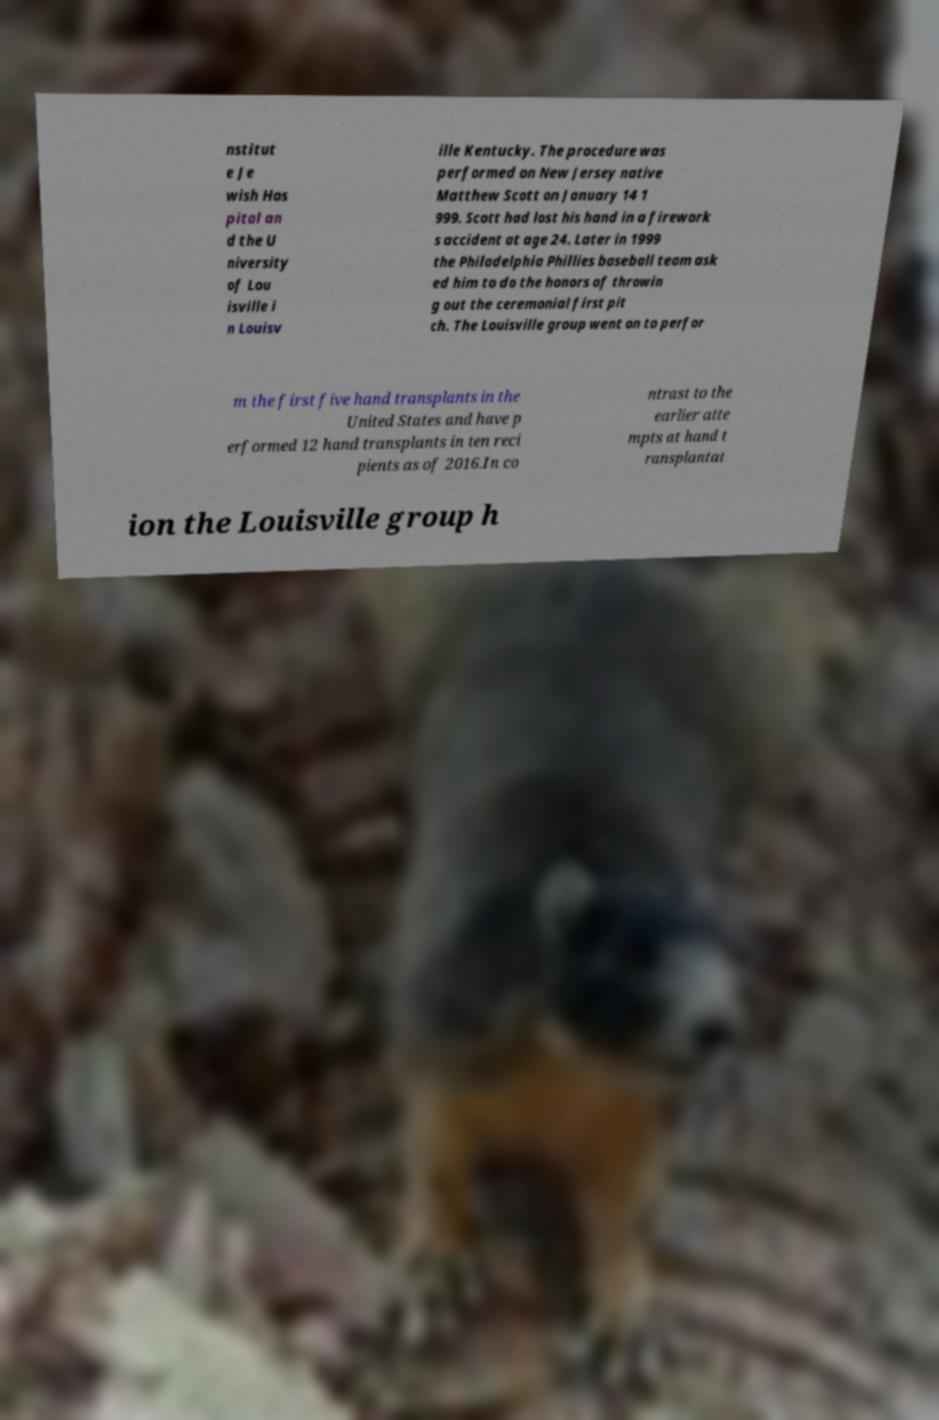For documentation purposes, I need the text within this image transcribed. Could you provide that? nstitut e Je wish Hos pital an d the U niversity of Lou isville i n Louisv ille Kentucky. The procedure was performed on New Jersey native Matthew Scott on January 14 1 999. Scott had lost his hand in a firework s accident at age 24. Later in 1999 the Philadelphia Phillies baseball team ask ed him to do the honors of throwin g out the ceremonial first pit ch. The Louisville group went on to perfor m the first five hand transplants in the United States and have p erformed 12 hand transplants in ten reci pients as of 2016.In co ntrast to the earlier atte mpts at hand t ransplantat ion the Louisville group h 